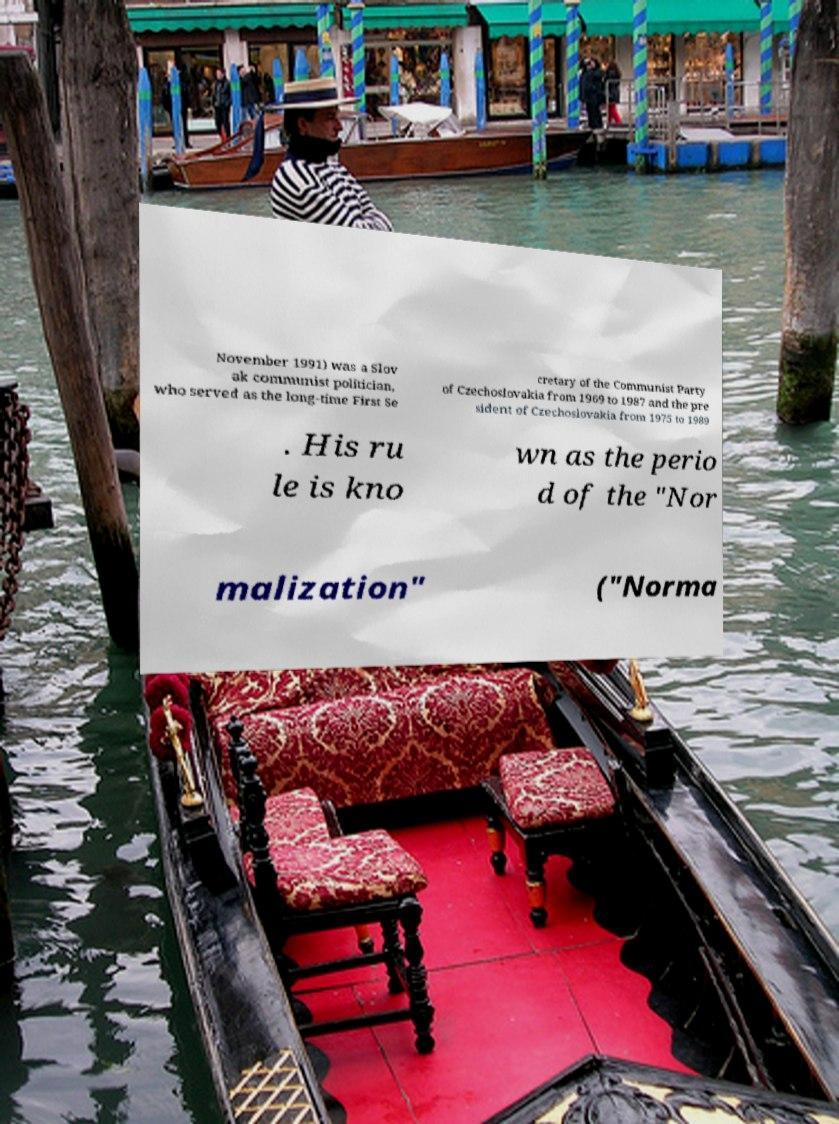Can you accurately transcribe the text from the provided image for me? November 1991) was a Slov ak communist politician, who served as the long-time First Se cretary of the Communist Party of Czechoslovakia from 1969 to 1987 and the pre sident of Czechoslovakia from 1975 to 1989 . His ru le is kno wn as the perio d of the "Nor malization" ("Norma 